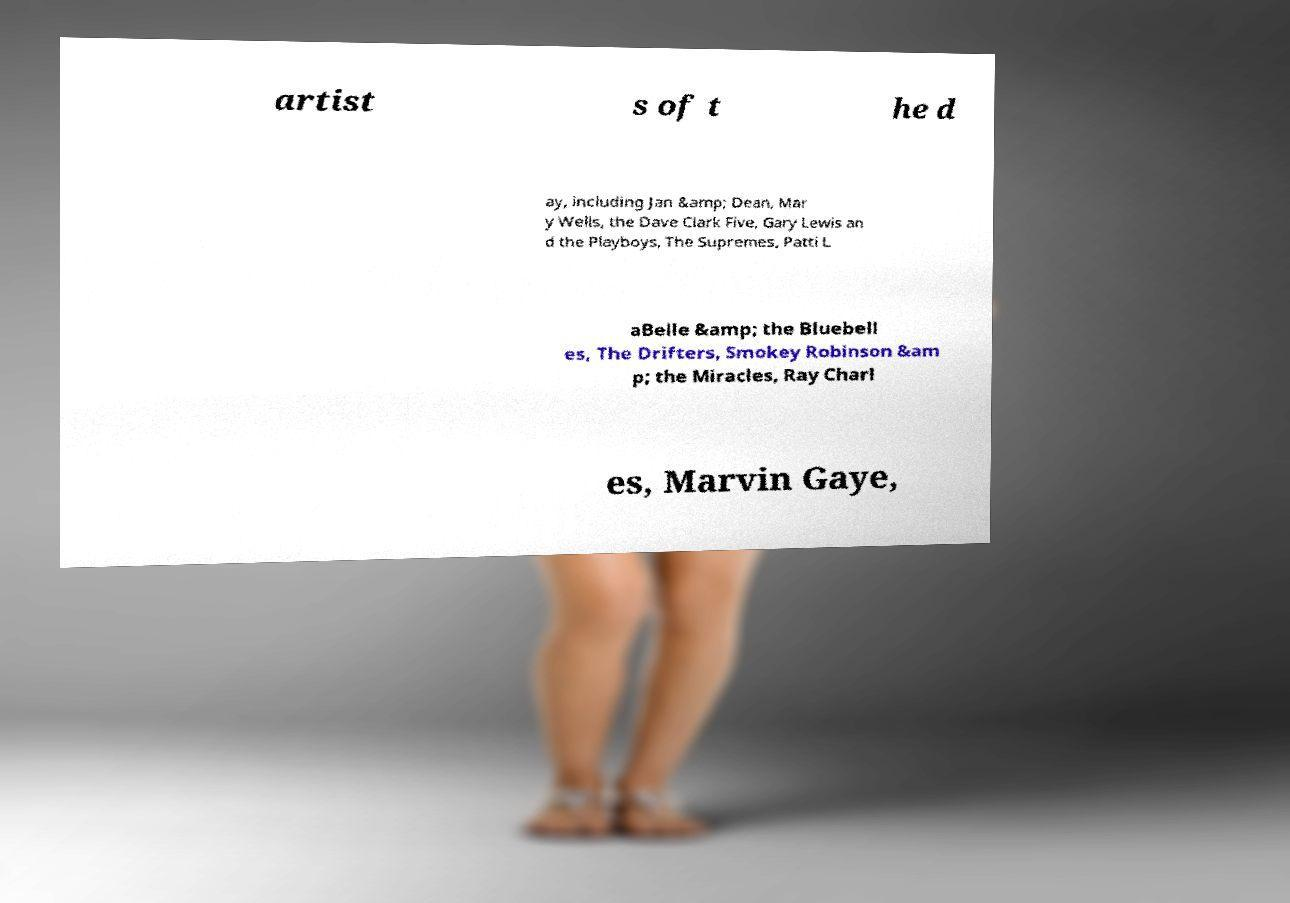Please identify and transcribe the text found in this image. artist s of t he d ay, including Jan &amp; Dean, Mar y Wells, the Dave Clark Five, Gary Lewis an d the Playboys, The Supremes, Patti L aBelle &amp; the Bluebell es, The Drifters, Smokey Robinson &am p; the Miracles, Ray Charl es, Marvin Gaye, 